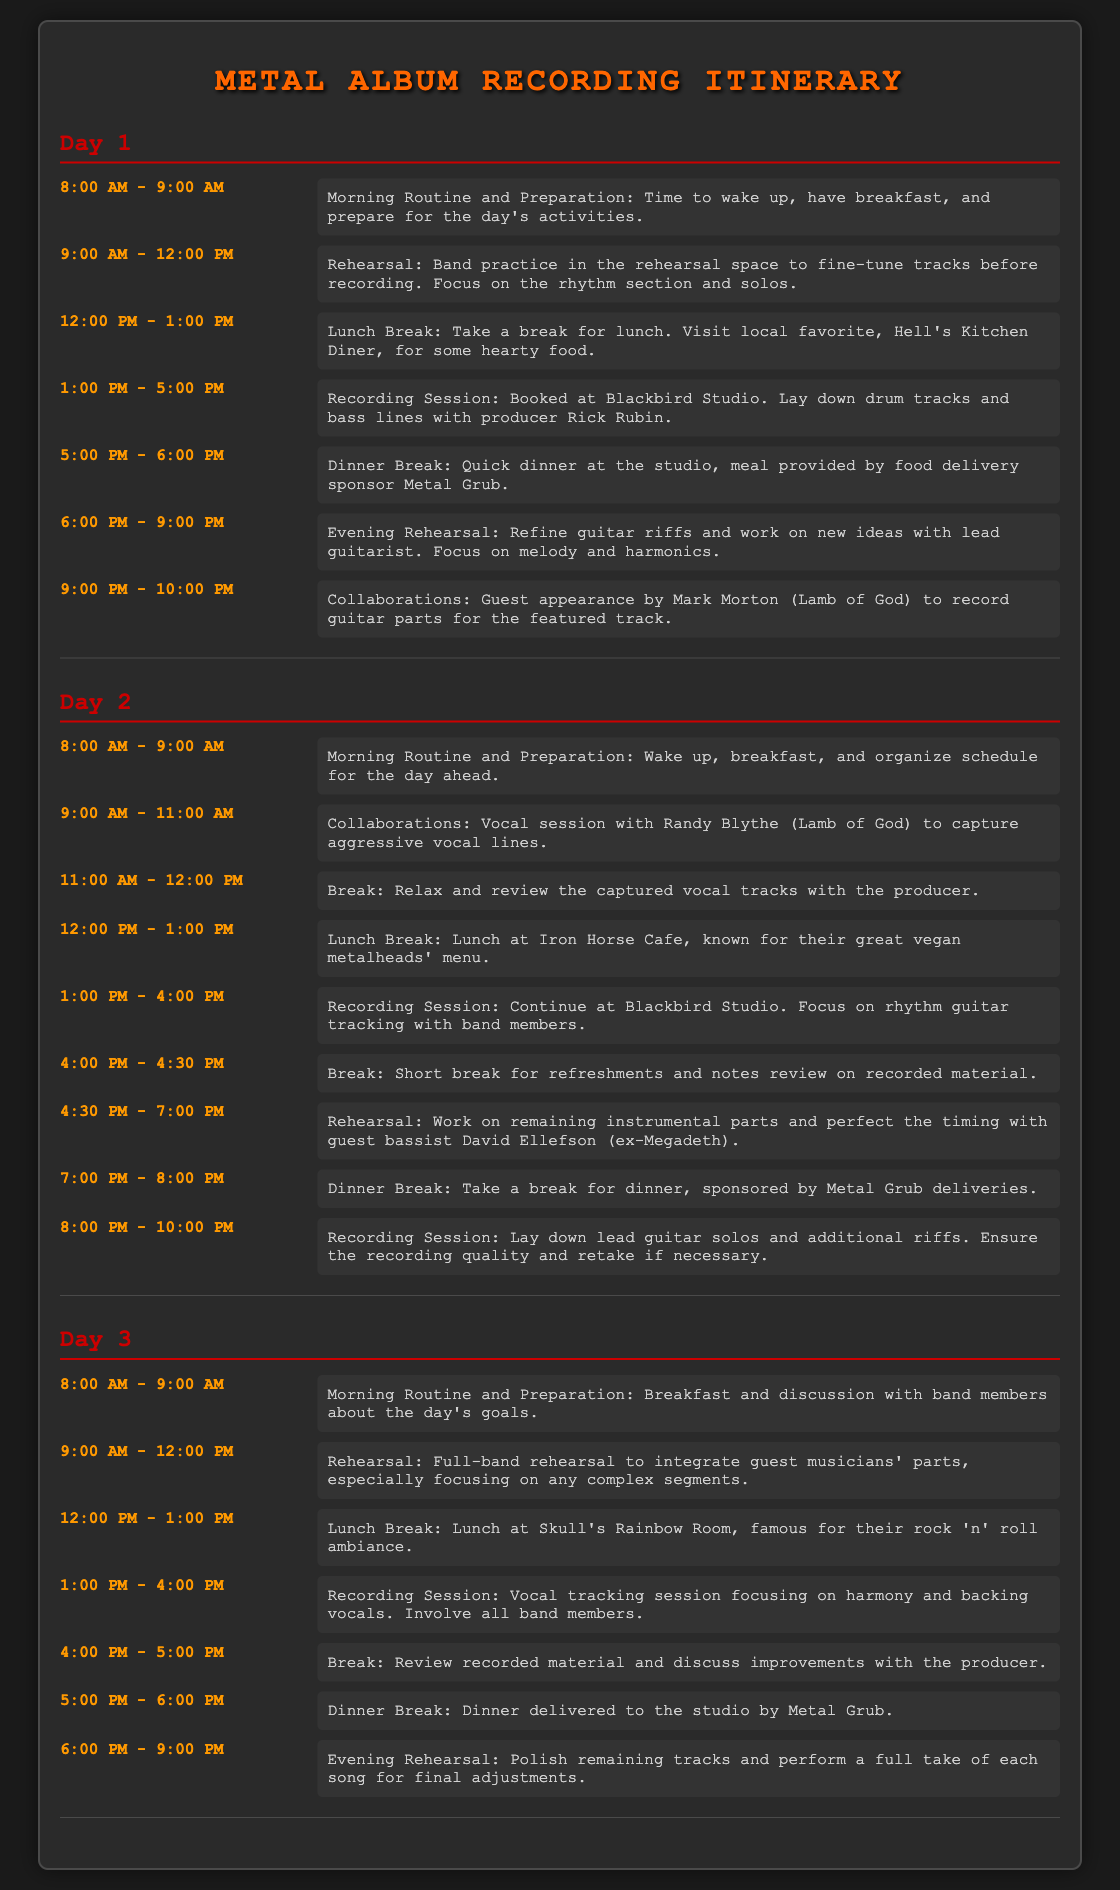What time does the morning routine start on Day 1? The morning routine on Day 1 starts at 8:00 AM.
Answer: 8:00 AM Who is the guest musician collaborating on Day 1? The guest musician collaborating on Day 1 is Mark Morton.
Answer: Mark Morton What is the duration of the rehearsal on Day 2? The rehearsal on Day 2 lasts from 4:30 PM to 7:00 PM, totaling 2.5 hours.
Answer: 2.5 hours Where is the lunch break on Day 3? The lunch break on Day 3 is at Skull's Rainbow Room.
Answer: Skull's Rainbow Room How many recording sessions are scheduled on Day 2? There are three recording sessions scheduled on Day 2.
Answer: Three What meals are provided by Metal Grub? Metal Grub provides dinner breaks on both Day 1 and Day 2.
Answer: Dinner breaks What activity occurs between 1:00 PM and 4:00 PM on Day 3? The activity between 1:00 PM and 4:00 PM on Day 3 is vocal tracking session.
Answer: Vocal tracking session What is the main focus during the evening rehearsal on Day 3? The main focus during the evening rehearsal on Day 3 is to polish remaining tracks and perform a full take of each song.
Answer: Polish remaining tracks What time does the evening rehearsal end on Day 1? The evening rehearsal on Day 1 ends at 9:00 PM.
Answer: 9:00 PM 